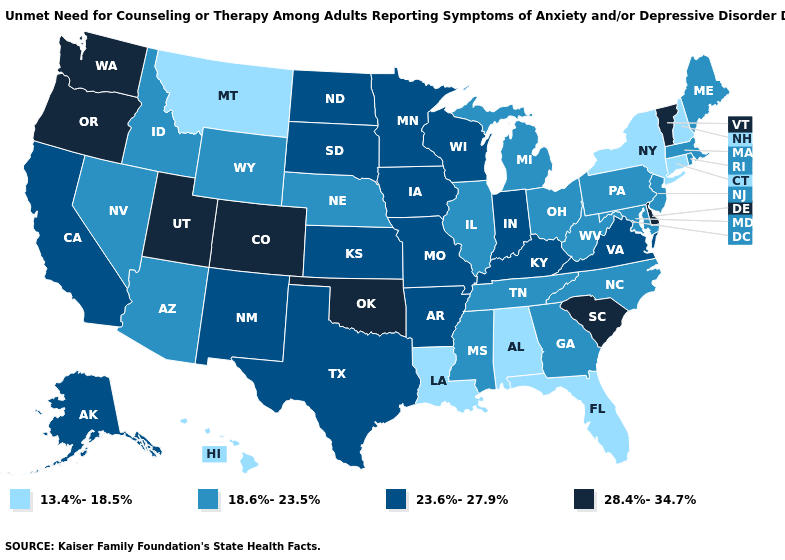What is the value of Kentucky?
Answer briefly. 23.6%-27.9%. What is the value of Alabama?
Quick response, please. 13.4%-18.5%. Name the states that have a value in the range 23.6%-27.9%?
Answer briefly. Alaska, Arkansas, California, Indiana, Iowa, Kansas, Kentucky, Minnesota, Missouri, New Mexico, North Dakota, South Dakota, Texas, Virginia, Wisconsin. Name the states that have a value in the range 23.6%-27.9%?
Short answer required. Alaska, Arkansas, California, Indiana, Iowa, Kansas, Kentucky, Minnesota, Missouri, New Mexico, North Dakota, South Dakota, Texas, Virginia, Wisconsin. Name the states that have a value in the range 23.6%-27.9%?
Give a very brief answer. Alaska, Arkansas, California, Indiana, Iowa, Kansas, Kentucky, Minnesota, Missouri, New Mexico, North Dakota, South Dakota, Texas, Virginia, Wisconsin. What is the highest value in the USA?
Be succinct. 28.4%-34.7%. What is the value of Utah?
Answer briefly. 28.4%-34.7%. Does Ohio have the highest value in the MidWest?
Answer briefly. No. Does the first symbol in the legend represent the smallest category?
Keep it brief. Yes. Does Missouri have the lowest value in the MidWest?
Write a very short answer. No. Which states have the highest value in the USA?
Answer briefly. Colorado, Delaware, Oklahoma, Oregon, South Carolina, Utah, Vermont, Washington. Name the states that have a value in the range 13.4%-18.5%?
Answer briefly. Alabama, Connecticut, Florida, Hawaii, Louisiana, Montana, New Hampshire, New York. Among the states that border Ohio , does Indiana have the lowest value?
Keep it brief. No. 